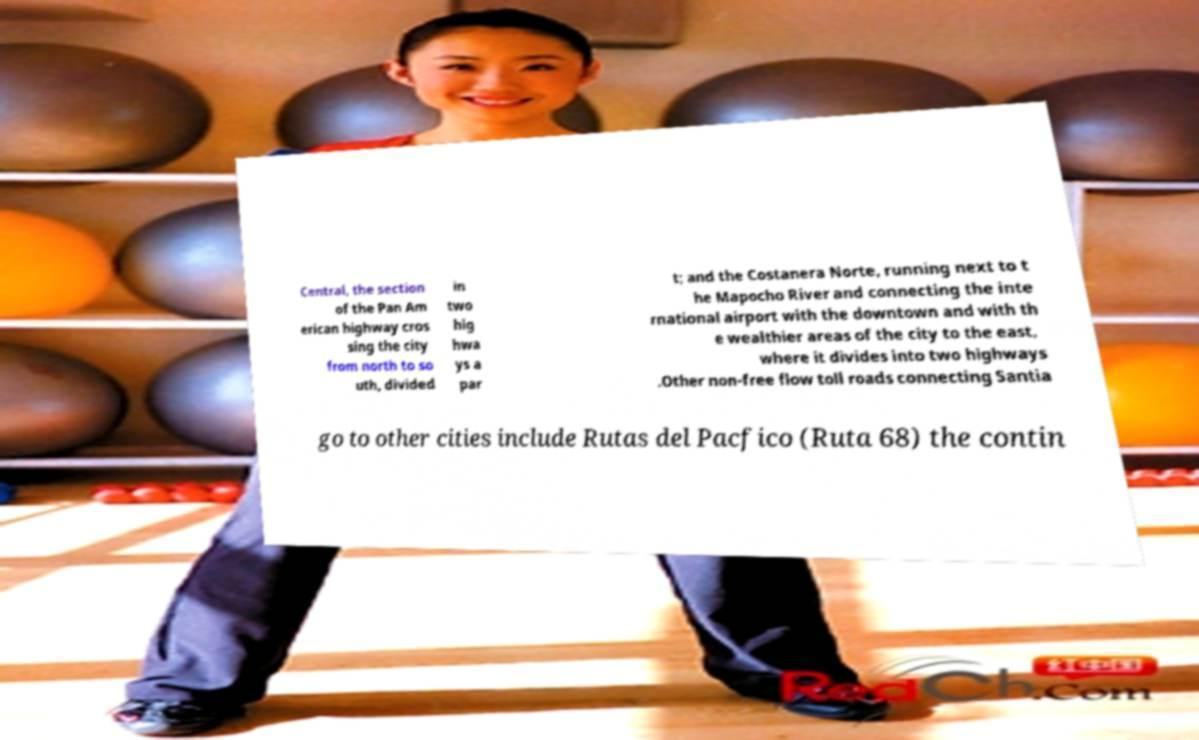Can you accurately transcribe the text from the provided image for me? Central, the section of the Pan Am erican highway cros sing the city from north to so uth, divided in two hig hwa ys a par t; and the Costanera Norte, running next to t he Mapocho River and connecting the inte rnational airport with the downtown and with th e wealthier areas of the city to the east, where it divides into two highways .Other non-free flow toll roads connecting Santia go to other cities include Rutas del Pacfico (Ruta 68) the contin 